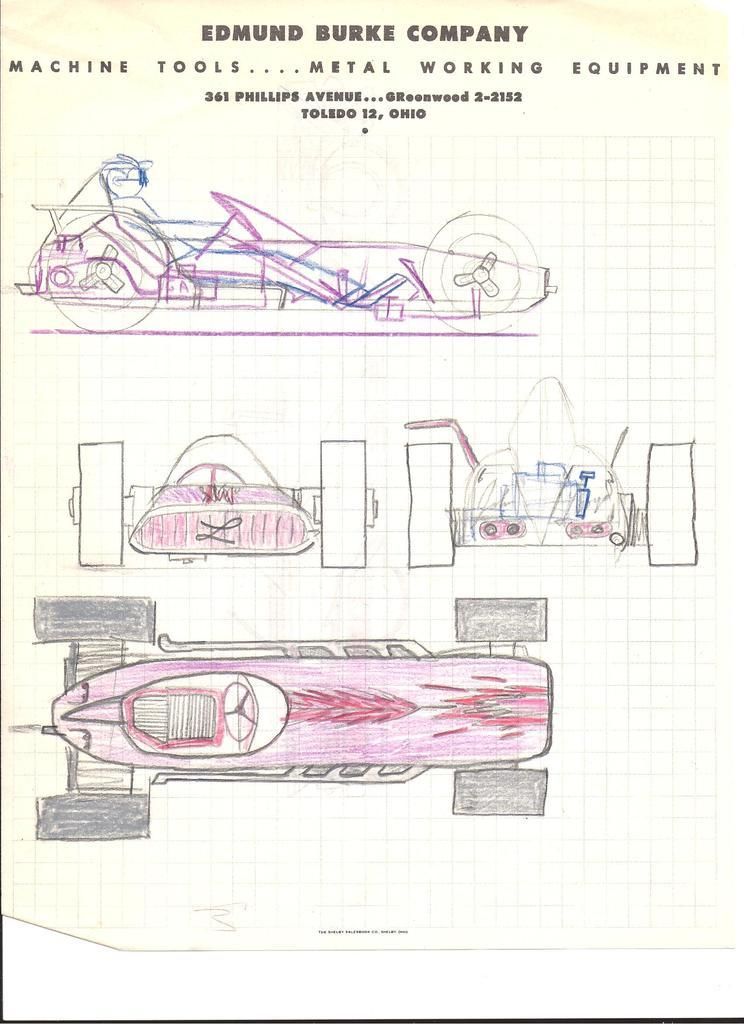What is the main subject of the image? The main subject of the image is a drawing. What else can be seen in the drawing? There are vehicles in the image. Is there any text present in the image? Yes, there is text in the image. What color are the eyes of the person in the image? There is no person present in the image, only a drawing with vehicles and text. 